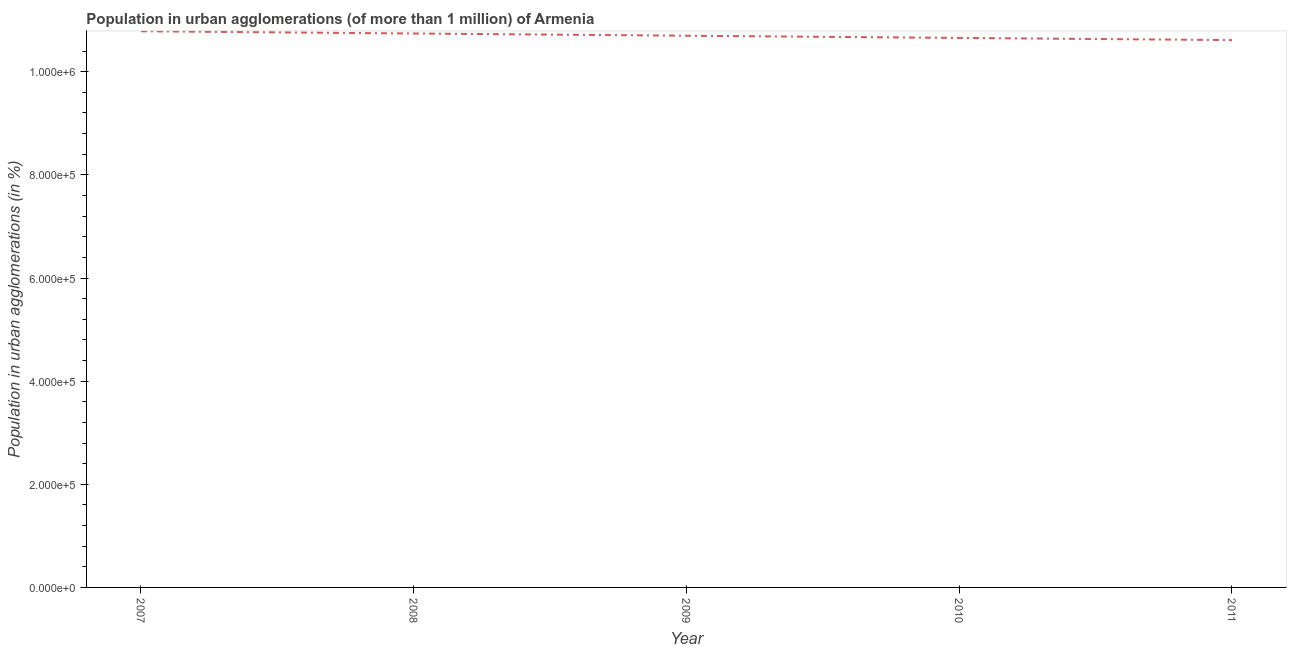What is the population in urban agglomerations in 2010?
Your answer should be compact. 1.07e+06. Across all years, what is the maximum population in urban agglomerations?
Your answer should be compact. 1.08e+06. Across all years, what is the minimum population in urban agglomerations?
Offer a very short reply. 1.06e+06. In which year was the population in urban agglomerations minimum?
Offer a terse response. 2011. What is the sum of the population in urban agglomerations?
Your answer should be compact. 5.35e+06. What is the difference between the population in urban agglomerations in 2009 and 2010?
Keep it short and to the point. 4276. What is the average population in urban agglomerations per year?
Your answer should be compact. 1.07e+06. What is the median population in urban agglomerations?
Your answer should be very brief. 1.07e+06. In how many years, is the population in urban agglomerations greater than 640000 %?
Provide a succinct answer. 5. Do a majority of the years between 2010 and 2011 (inclusive) have population in urban agglomerations greater than 80000 %?
Provide a succinct answer. Yes. What is the ratio of the population in urban agglomerations in 2007 to that in 2008?
Provide a succinct answer. 1. What is the difference between the highest and the second highest population in urban agglomerations?
Keep it short and to the point. 4317. Is the sum of the population in urban agglomerations in 2008 and 2009 greater than the maximum population in urban agglomerations across all years?
Make the answer very short. Yes. What is the difference between the highest and the lowest population in urban agglomerations?
Offer a very short reply. 1.71e+04. Does the population in urban agglomerations monotonically increase over the years?
Make the answer very short. No. What is the difference between two consecutive major ticks on the Y-axis?
Give a very brief answer. 2.00e+05. Are the values on the major ticks of Y-axis written in scientific E-notation?
Your answer should be compact. Yes. What is the title of the graph?
Give a very brief answer. Population in urban agglomerations (of more than 1 million) of Armenia. What is the label or title of the Y-axis?
Make the answer very short. Population in urban agglomerations (in %). What is the Population in urban agglomerations (in %) of 2007?
Ensure brevity in your answer.  1.08e+06. What is the Population in urban agglomerations (in %) in 2008?
Ensure brevity in your answer.  1.07e+06. What is the Population in urban agglomerations (in %) in 2009?
Ensure brevity in your answer.  1.07e+06. What is the Population in urban agglomerations (in %) in 2010?
Offer a terse response. 1.07e+06. What is the Population in urban agglomerations (in %) of 2011?
Provide a short and direct response. 1.06e+06. What is the difference between the Population in urban agglomerations (in %) in 2007 and 2008?
Your response must be concise. 4317. What is the difference between the Population in urban agglomerations (in %) in 2007 and 2009?
Provide a short and direct response. 8606. What is the difference between the Population in urban agglomerations (in %) in 2007 and 2010?
Make the answer very short. 1.29e+04. What is the difference between the Population in urban agglomerations (in %) in 2007 and 2011?
Your answer should be very brief. 1.71e+04. What is the difference between the Population in urban agglomerations (in %) in 2008 and 2009?
Make the answer very short. 4289. What is the difference between the Population in urban agglomerations (in %) in 2008 and 2010?
Provide a short and direct response. 8565. What is the difference between the Population in urban agglomerations (in %) in 2008 and 2011?
Your answer should be compact. 1.28e+04. What is the difference between the Population in urban agglomerations (in %) in 2009 and 2010?
Give a very brief answer. 4276. What is the difference between the Population in urban agglomerations (in %) in 2009 and 2011?
Provide a succinct answer. 8536. What is the difference between the Population in urban agglomerations (in %) in 2010 and 2011?
Provide a short and direct response. 4260. What is the ratio of the Population in urban agglomerations (in %) in 2007 to that in 2008?
Make the answer very short. 1. What is the ratio of the Population in urban agglomerations (in %) in 2008 to that in 2009?
Make the answer very short. 1. What is the ratio of the Population in urban agglomerations (in %) in 2008 to that in 2011?
Provide a succinct answer. 1.01. What is the ratio of the Population in urban agglomerations (in %) in 2009 to that in 2010?
Give a very brief answer. 1. What is the ratio of the Population in urban agglomerations (in %) in 2009 to that in 2011?
Provide a succinct answer. 1.01. 